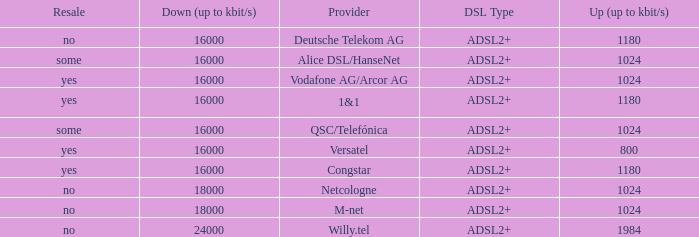What is the resale category for the provider NetCologne? No. 